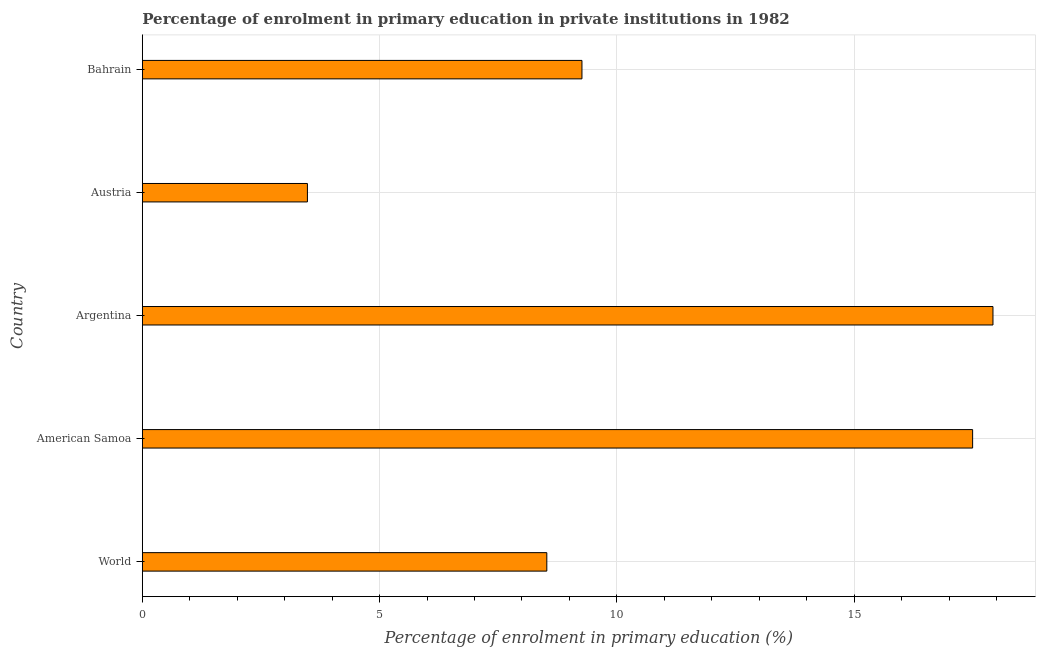Does the graph contain any zero values?
Your response must be concise. No. Does the graph contain grids?
Offer a terse response. Yes. What is the title of the graph?
Keep it short and to the point. Percentage of enrolment in primary education in private institutions in 1982. What is the label or title of the X-axis?
Provide a short and direct response. Percentage of enrolment in primary education (%). What is the enrolment percentage in primary education in American Samoa?
Your answer should be very brief. 17.5. Across all countries, what is the maximum enrolment percentage in primary education?
Ensure brevity in your answer.  17.93. Across all countries, what is the minimum enrolment percentage in primary education?
Offer a very short reply. 3.48. In which country was the enrolment percentage in primary education maximum?
Ensure brevity in your answer.  Argentina. In which country was the enrolment percentage in primary education minimum?
Provide a succinct answer. Austria. What is the sum of the enrolment percentage in primary education?
Your answer should be compact. 56.69. What is the difference between the enrolment percentage in primary education in Austria and World?
Offer a very short reply. -5.04. What is the average enrolment percentage in primary education per country?
Give a very brief answer. 11.34. What is the median enrolment percentage in primary education?
Make the answer very short. 9.26. In how many countries, is the enrolment percentage in primary education greater than 3 %?
Make the answer very short. 5. What is the ratio of the enrolment percentage in primary education in Argentina to that in Bahrain?
Your answer should be compact. 1.94. Is the enrolment percentage in primary education in American Samoa less than that in Bahrain?
Provide a short and direct response. No. What is the difference between the highest and the second highest enrolment percentage in primary education?
Keep it short and to the point. 0.43. What is the difference between the highest and the lowest enrolment percentage in primary education?
Provide a succinct answer. 14.45. In how many countries, is the enrolment percentage in primary education greater than the average enrolment percentage in primary education taken over all countries?
Give a very brief answer. 2. How many countries are there in the graph?
Provide a succinct answer. 5. Are the values on the major ticks of X-axis written in scientific E-notation?
Keep it short and to the point. No. What is the Percentage of enrolment in primary education (%) of World?
Offer a very short reply. 8.52. What is the Percentage of enrolment in primary education (%) of American Samoa?
Your response must be concise. 17.5. What is the Percentage of enrolment in primary education (%) of Argentina?
Keep it short and to the point. 17.93. What is the Percentage of enrolment in primary education (%) in Austria?
Your answer should be very brief. 3.48. What is the Percentage of enrolment in primary education (%) in Bahrain?
Give a very brief answer. 9.26. What is the difference between the Percentage of enrolment in primary education (%) in World and American Samoa?
Make the answer very short. -8.97. What is the difference between the Percentage of enrolment in primary education (%) in World and Argentina?
Give a very brief answer. -9.4. What is the difference between the Percentage of enrolment in primary education (%) in World and Austria?
Ensure brevity in your answer.  5.04. What is the difference between the Percentage of enrolment in primary education (%) in World and Bahrain?
Make the answer very short. -0.74. What is the difference between the Percentage of enrolment in primary education (%) in American Samoa and Argentina?
Provide a succinct answer. -0.43. What is the difference between the Percentage of enrolment in primary education (%) in American Samoa and Austria?
Provide a short and direct response. 14.02. What is the difference between the Percentage of enrolment in primary education (%) in American Samoa and Bahrain?
Offer a very short reply. 8.23. What is the difference between the Percentage of enrolment in primary education (%) in Argentina and Austria?
Provide a succinct answer. 14.45. What is the difference between the Percentage of enrolment in primary education (%) in Argentina and Bahrain?
Provide a short and direct response. 8.66. What is the difference between the Percentage of enrolment in primary education (%) in Austria and Bahrain?
Your response must be concise. -5.79. What is the ratio of the Percentage of enrolment in primary education (%) in World to that in American Samoa?
Give a very brief answer. 0.49. What is the ratio of the Percentage of enrolment in primary education (%) in World to that in Argentina?
Provide a succinct answer. 0.47. What is the ratio of the Percentage of enrolment in primary education (%) in World to that in Austria?
Offer a terse response. 2.45. What is the ratio of the Percentage of enrolment in primary education (%) in American Samoa to that in Argentina?
Provide a short and direct response. 0.98. What is the ratio of the Percentage of enrolment in primary education (%) in American Samoa to that in Austria?
Provide a short and direct response. 5.03. What is the ratio of the Percentage of enrolment in primary education (%) in American Samoa to that in Bahrain?
Offer a very short reply. 1.89. What is the ratio of the Percentage of enrolment in primary education (%) in Argentina to that in Austria?
Provide a short and direct response. 5.15. What is the ratio of the Percentage of enrolment in primary education (%) in Argentina to that in Bahrain?
Offer a very short reply. 1.94. What is the ratio of the Percentage of enrolment in primary education (%) in Austria to that in Bahrain?
Keep it short and to the point. 0.38. 